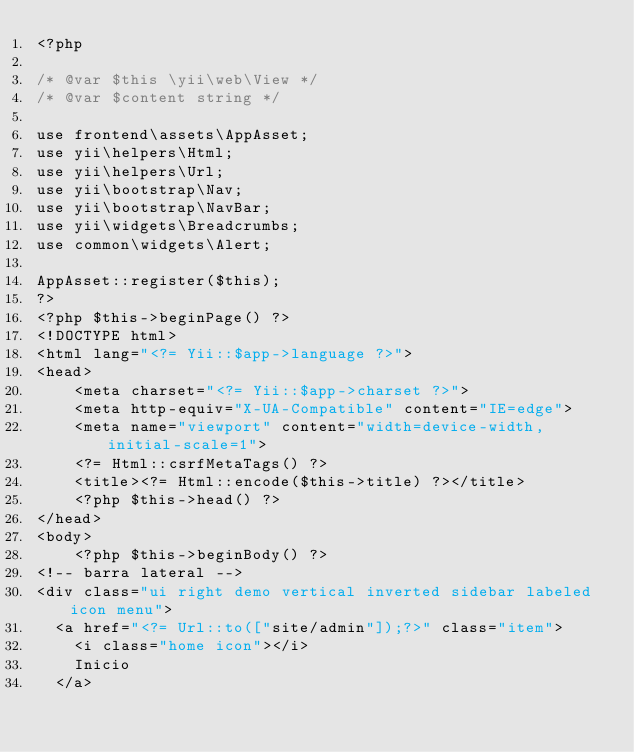Convert code to text. <code><loc_0><loc_0><loc_500><loc_500><_PHP_><?php

/* @var $this \yii\web\View */
/* @var $content string */

use frontend\assets\AppAsset;
use yii\helpers\Html;
use yii\helpers\Url;
use yii\bootstrap\Nav;
use yii\bootstrap\NavBar;
use yii\widgets\Breadcrumbs;
use common\widgets\Alert;

AppAsset::register($this);
?>
<?php $this->beginPage() ?>
<!DOCTYPE html>
<html lang="<?= Yii::$app->language ?>">
<head>
    <meta charset="<?= Yii::$app->charset ?>">
    <meta http-equiv="X-UA-Compatible" content="IE=edge">
    <meta name="viewport" content="width=device-width, initial-scale=1">
    <?= Html::csrfMetaTags() ?>
    <title><?= Html::encode($this->title) ?></title>
    <?php $this->head() ?>
</head>
<body>
    <?php $this->beginBody() ?>
<!-- barra lateral -->
<div class="ui right demo vertical inverted sidebar labeled icon menu">
  <a href="<?= Url::to(["site/admin"]);?>" class="item">
    <i class="home icon"></i>
    Inicio
  </a></code> 